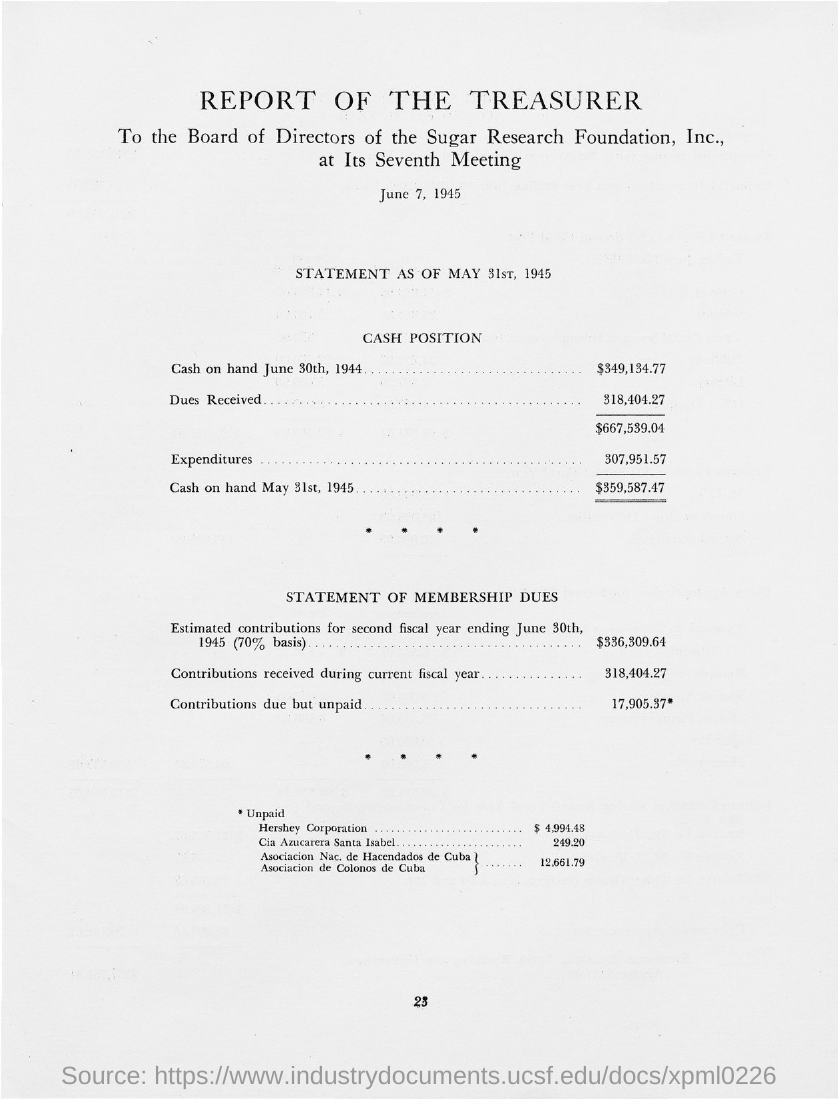What is the document about?
Provide a short and direct response. REPORT OF THE TREASURER. When is the document dated?
Give a very brief answer. June 7, 1945. What is the amount received as dues in $?
Your response must be concise. 318,404.27. 